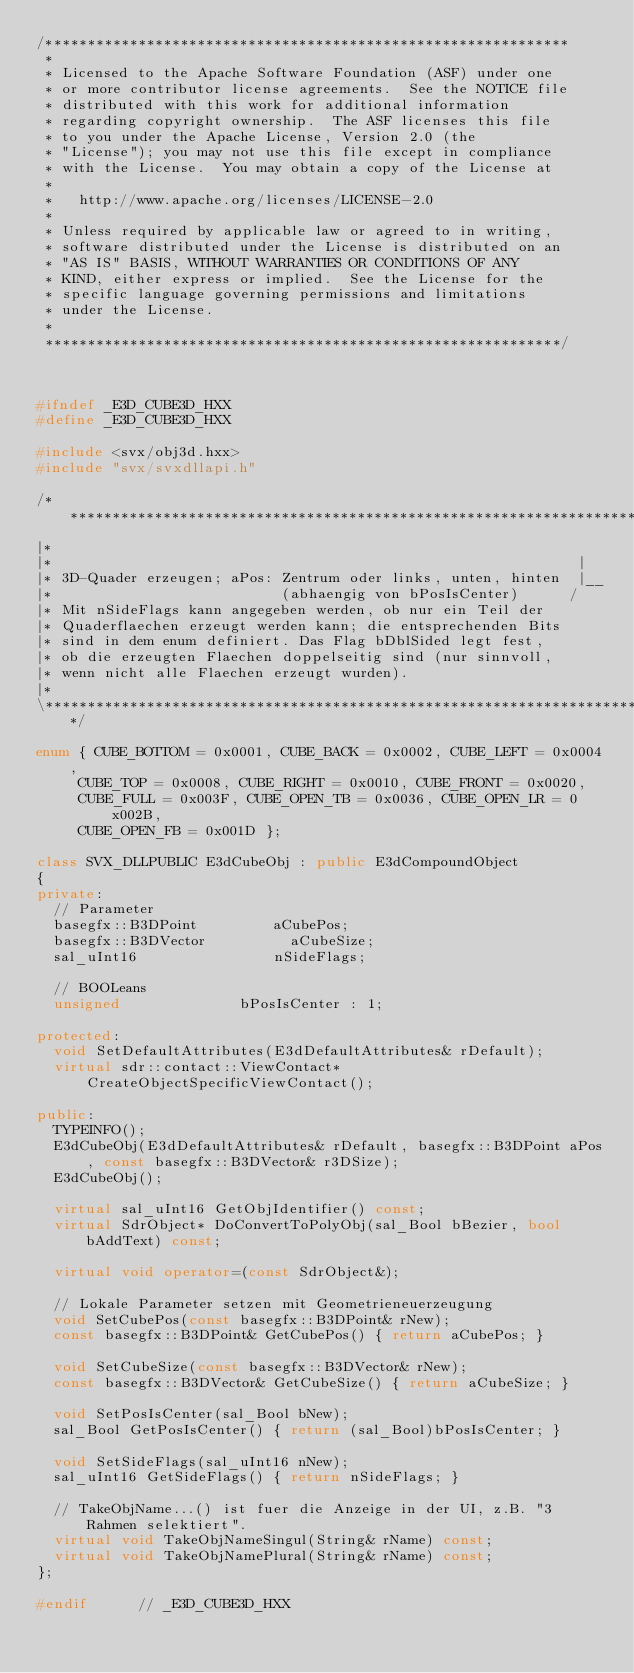Convert code to text. <code><loc_0><loc_0><loc_500><loc_500><_C++_>/**************************************************************
 * 
 * Licensed to the Apache Software Foundation (ASF) under one
 * or more contributor license agreements.  See the NOTICE file
 * distributed with this work for additional information
 * regarding copyright ownership.  The ASF licenses this file
 * to you under the Apache License, Version 2.0 (the
 * "License"); you may not use this file except in compliance
 * with the License.  You may obtain a copy of the License at
 * 
 *   http://www.apache.org/licenses/LICENSE-2.0
 * 
 * Unless required by applicable law or agreed to in writing,
 * software distributed under the License is distributed on an
 * "AS IS" BASIS, WITHOUT WARRANTIES OR CONDITIONS OF ANY
 * KIND, either express or implied.  See the License for the
 * specific language governing permissions and limitations
 * under the License.
 * 
 *************************************************************/



#ifndef _E3D_CUBE3D_HXX
#define _E3D_CUBE3D_HXX

#include <svx/obj3d.hxx>
#include "svx/svxdllapi.h"

/*************************************************************************
|*
|*                                                              |
|* 3D-Quader erzeugen; aPos: Zentrum oder links, unten, hinten  |__
|*                           (abhaengig von bPosIsCenter)      /
|* Mit nSideFlags kann angegeben werden, ob nur ein Teil der
|* Quaderflaechen erzeugt werden kann; die entsprechenden Bits
|* sind in dem enum definiert. Das Flag bDblSided legt fest,
|* ob die erzeugten Flaechen doppelseitig sind (nur sinnvoll,
|* wenn nicht alle Flaechen erzeugt wurden).
|*
\************************************************************************/

enum { CUBE_BOTTOM = 0x0001, CUBE_BACK = 0x0002, CUBE_LEFT = 0x0004,
	   CUBE_TOP = 0x0008, CUBE_RIGHT = 0x0010, CUBE_FRONT = 0x0020,
	   CUBE_FULL = 0x003F, CUBE_OPEN_TB = 0x0036, CUBE_OPEN_LR = 0x002B,
	   CUBE_OPEN_FB = 0x001D };

class SVX_DLLPUBLIC E3dCubeObj : public E3dCompoundObject
{
private:
	// Parameter
	basegfx::B3DPoint					aCubePos;
	basegfx::B3DVector					aCubeSize;
	sal_uInt16								nSideFlags;

	// BOOLeans
	unsigned							bPosIsCenter : 1;

protected:
	void SetDefaultAttributes(E3dDefaultAttributes& rDefault);
	virtual sdr::contact::ViewContact* CreateObjectSpecificViewContact();

public:
	TYPEINFO();
	E3dCubeObj(E3dDefaultAttributes& rDefault, basegfx::B3DPoint aPos, const basegfx::B3DVector& r3DSize);
	E3dCubeObj();

	virtual sal_uInt16 GetObjIdentifier() const;
	virtual SdrObject* DoConvertToPolyObj(sal_Bool bBezier, bool bAddText) const;

	virtual void operator=(const SdrObject&);

	// Lokale Parameter setzen mit Geometrieneuerzeugung
	void SetCubePos(const basegfx::B3DPoint& rNew);
	const basegfx::B3DPoint& GetCubePos() { return aCubePos; }

	void SetCubeSize(const basegfx::B3DVector& rNew);
	const basegfx::B3DVector& GetCubeSize() { return aCubeSize; }

	void SetPosIsCenter(sal_Bool bNew);
	sal_Bool GetPosIsCenter() { return (sal_Bool)bPosIsCenter; }

	void SetSideFlags(sal_uInt16 nNew);
	sal_uInt16 GetSideFlags() { return nSideFlags; }

	// TakeObjName...() ist fuer die Anzeige in der UI, z.B. "3 Rahmen selektiert".
	virtual void TakeObjNameSingul(String& rName) const;
	virtual void TakeObjNamePlural(String& rName) const;
};

#endif			// _E3D_CUBE3D_HXX
</code> 